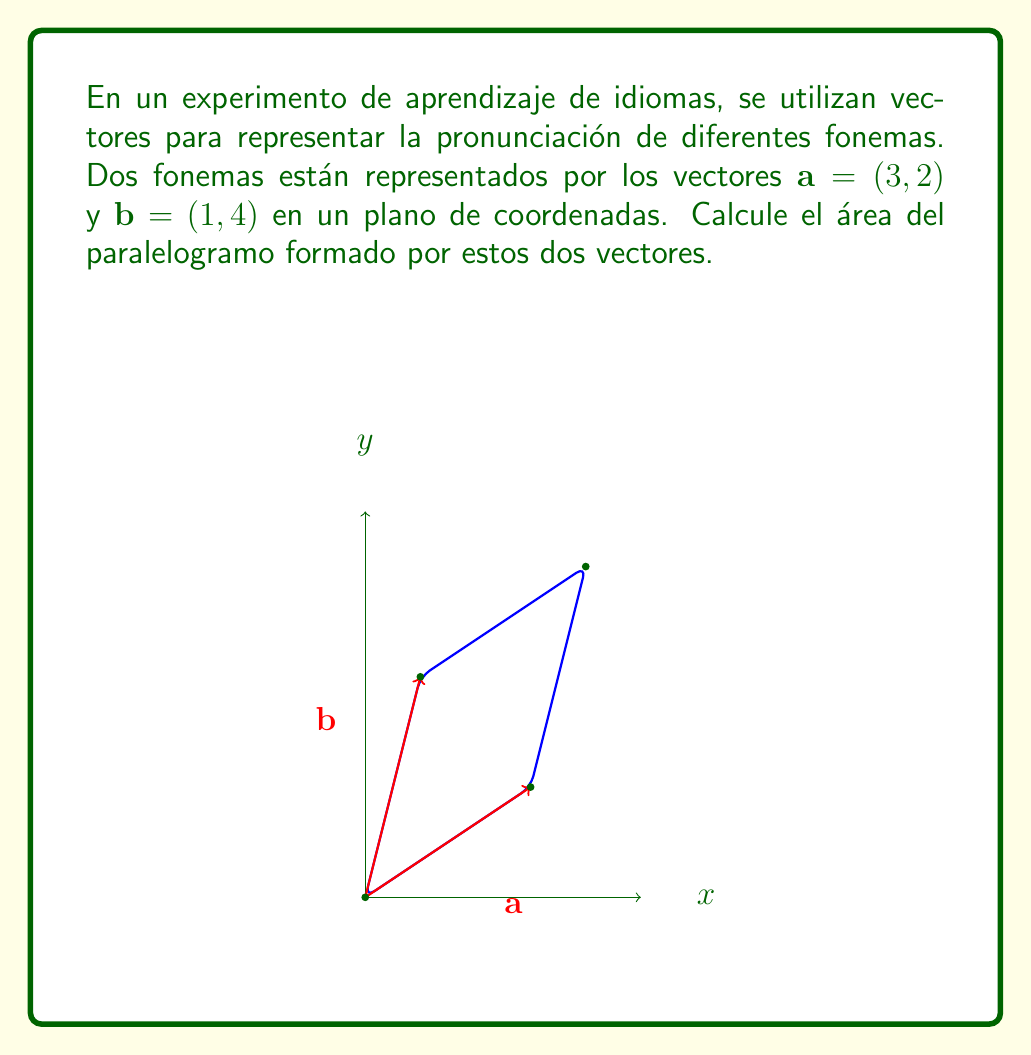Could you help me with this problem? Para calcular el área del paralelogramo formado por dos vectores, podemos usar el valor absoluto del determinante de la matriz formada por los componentes de los vectores. Este método es equivalente a calcular la magnitud del producto cruz de los dos vectores.

Paso 1: Identificar los componentes de los vectores
$\mathbf{a} = (3, 2)$ y $\mathbf{b} = (1, 4)$

Paso 2: Formar la matriz con los componentes de los vectores
$$\begin{vmatrix} 
3 & 1 \\
2 & 4
\end{vmatrix}$$

Paso 3: Calcular el determinante
$\text{det} = (3 \times 4) - (1 \times 2) = 12 - 2 = 10$

Paso 4: Tomar el valor absoluto del determinante
$|\text{det}| = |10| = 10$

El área del paralelogramo es igual al valor absoluto del determinante, que es 10 unidades cuadradas.
Answer: $10$ square units 